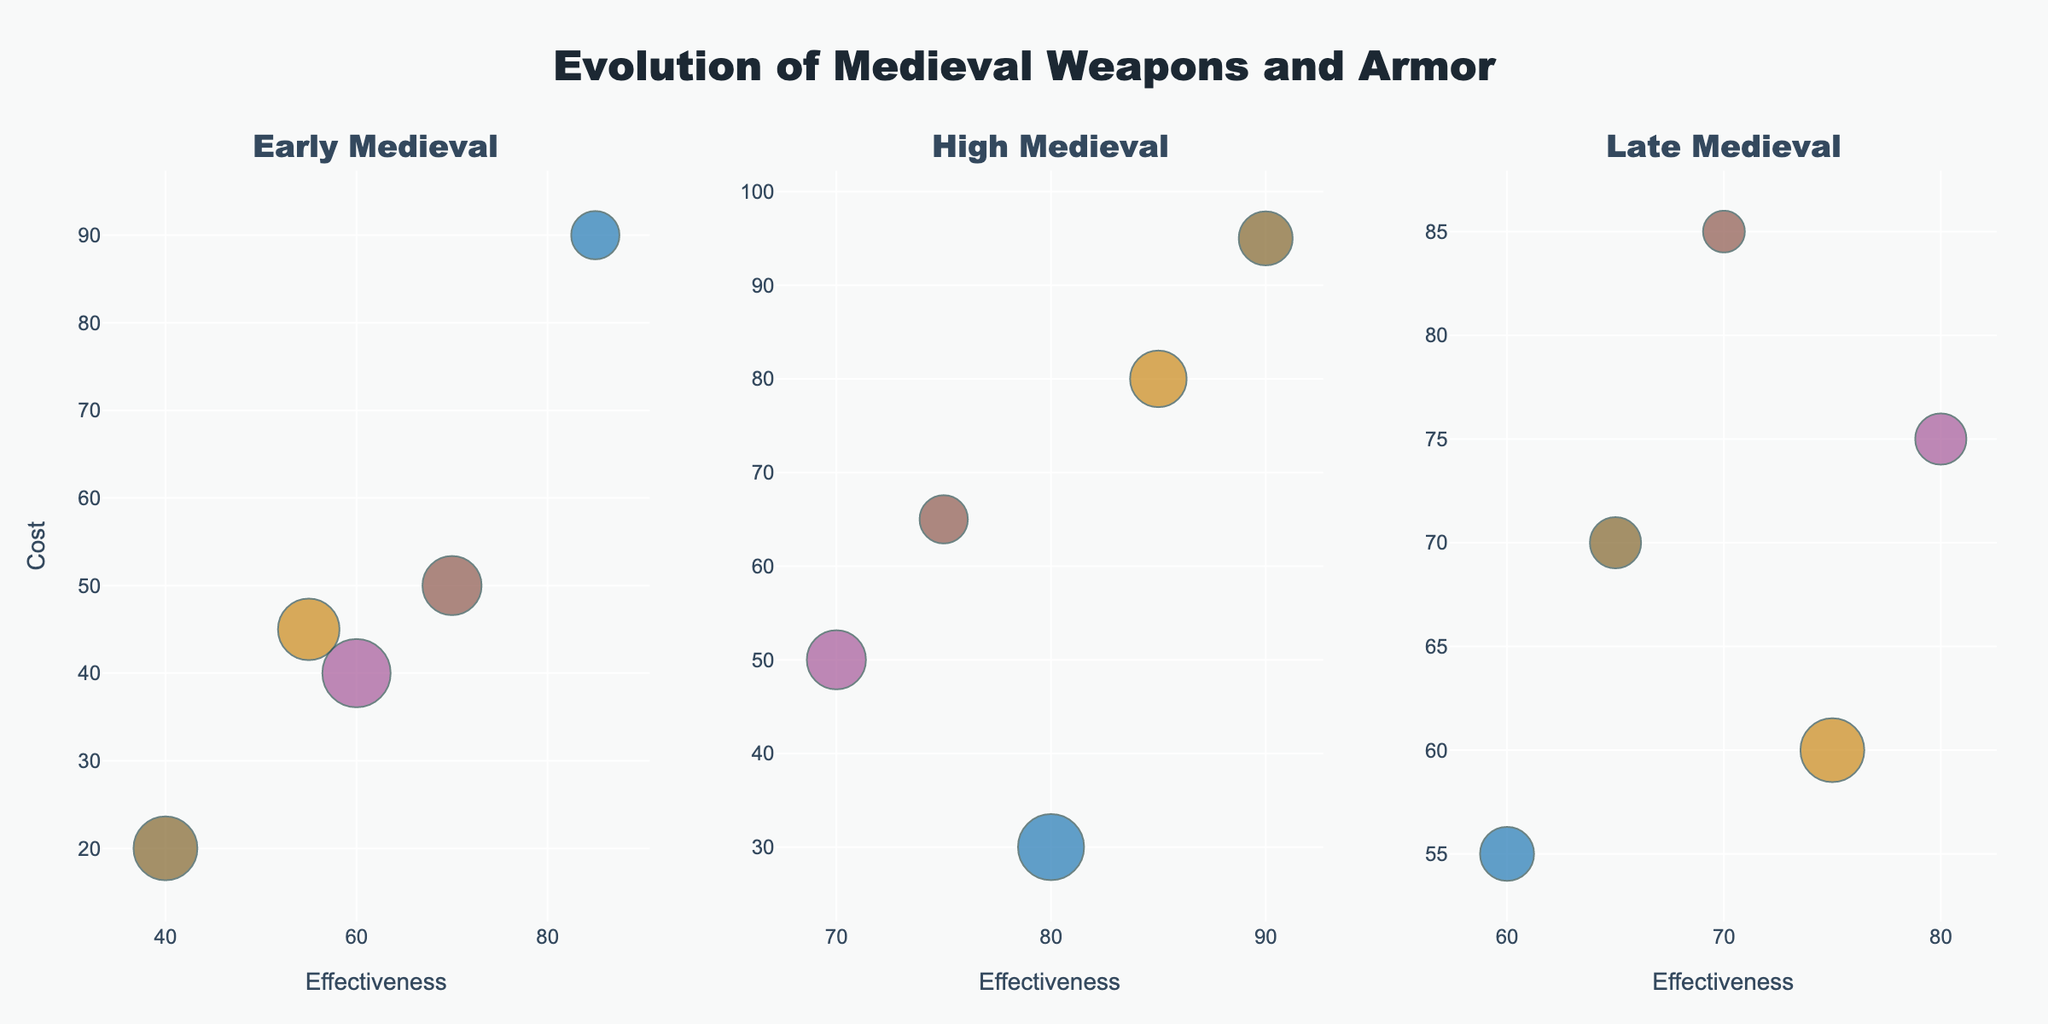How many time periods are represented in the figure? The title of the subplots indicates the periods. There are three subplot titles, each corresponding to one period, so there are three time periods represented.
Answer: 3 Which weapon/armor has the highest prevalence in the Early Medieval period? By examining the size of the bubbles in the Early Medieval subplot, the largest bubble represents the Viking Axe.
Answer: Viking Axe What is the relationship between prevalence and effectiveness for the Longbow in the High Medieval period? In the High Medieval subplot, look at the bubble for the Longbow. The prevalence is given by the bubble size, and the effectiveness is on the x-axis. The Longbow has high prevalence and high effectiveness.
Answer: High prevalence, High effectiveness Compare the cost of Plate Armor and Pavise Shield. Which is more expensive? Look at the respective bubbles in the High Medieval and Late Medieval periods. Plate Armor (High Medieval) is located at a higher cost value compared to Pavise Shield (Late Medieval).
Answer: Plate Armor Which period shows the highest overall effectiveness for weapons and armor? By comparing the x-axis values across the three subplots, the High Medieval subplot contains bubbles that are predominantly positioned towards higher effectiveness values.
Answer: High Medieval In which region do we find the most expensive weapons/armor in the Early Medieval period? Check the bubble with the highest y-axis position (cost) in the Early Medieval subplot. The Cataphract Armor of the Byzantine Empire is the most expensive.
Answer: Byzantine Empire Calculate the average effectiveness of all weapons/armors in the Late Medieval period. Identify the effectiveness values for all items in the Late Medieval subplot: Crossbow (75), Zweihander (65), Hussar Wing (70), Pavise Shield (60), Hungarian Saber (80). Sum these values (75+65+70+60+80=350) and divide by the number of items (350/5=70).
Answer: 70 Which weapon/armor from the Late Medieval period has the lowest cost, and what is its prevalence? In the Late Medieval subplot, the item with the lowest y-axis position (Crossbow) represents cost. The size of the bubble indicates prevalence (70).
Answer: Crossbow, 70 How does the effectiveness of the Toledo Steel Sword compare to the Kievan Rus Helmet? The Toledo Steel Sword (High Medieval) has an effectiveness of 85, while the Kievan Rus Helmet (Early Medieval) has an effectiveness of 55.
Answer: Toledo Steel Sword is more effective Is there any weapon/armor that is both highly prevalent and highly effective in the High Medieval period? In the High Medieval subplot, look for bubbles with large sizes and high x-axis values. The Longbow fits this criterion, with high prevalence (75) and high effectiveness (80).
Answer: Longbow 